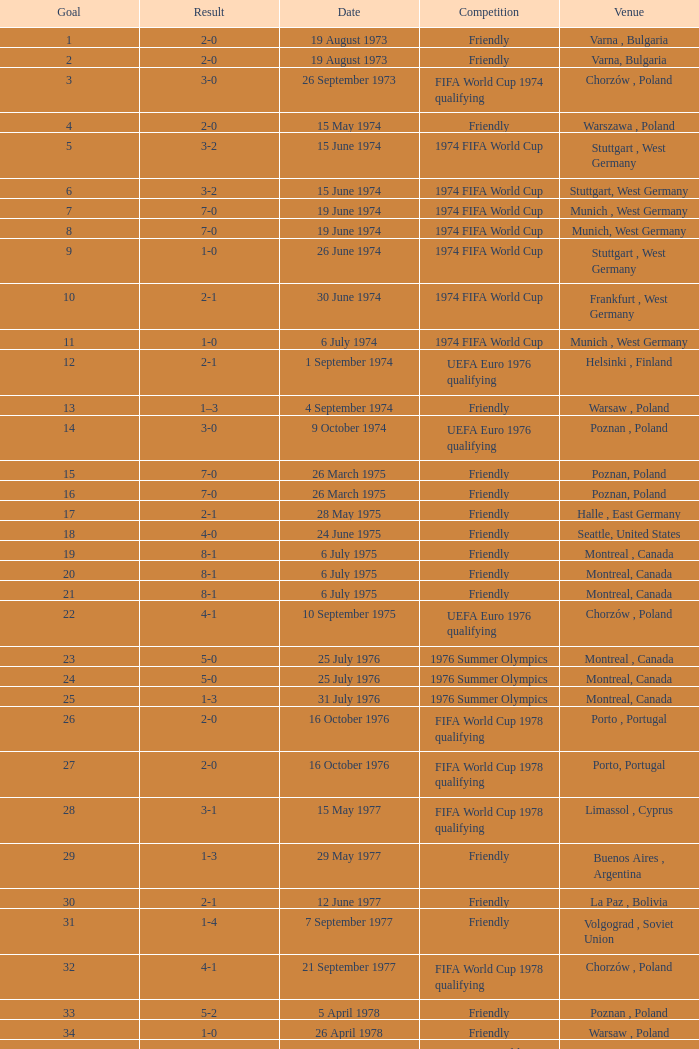What was the result of the game in Stuttgart, West Germany and a goal number of less than 9? 3-2, 3-2. 